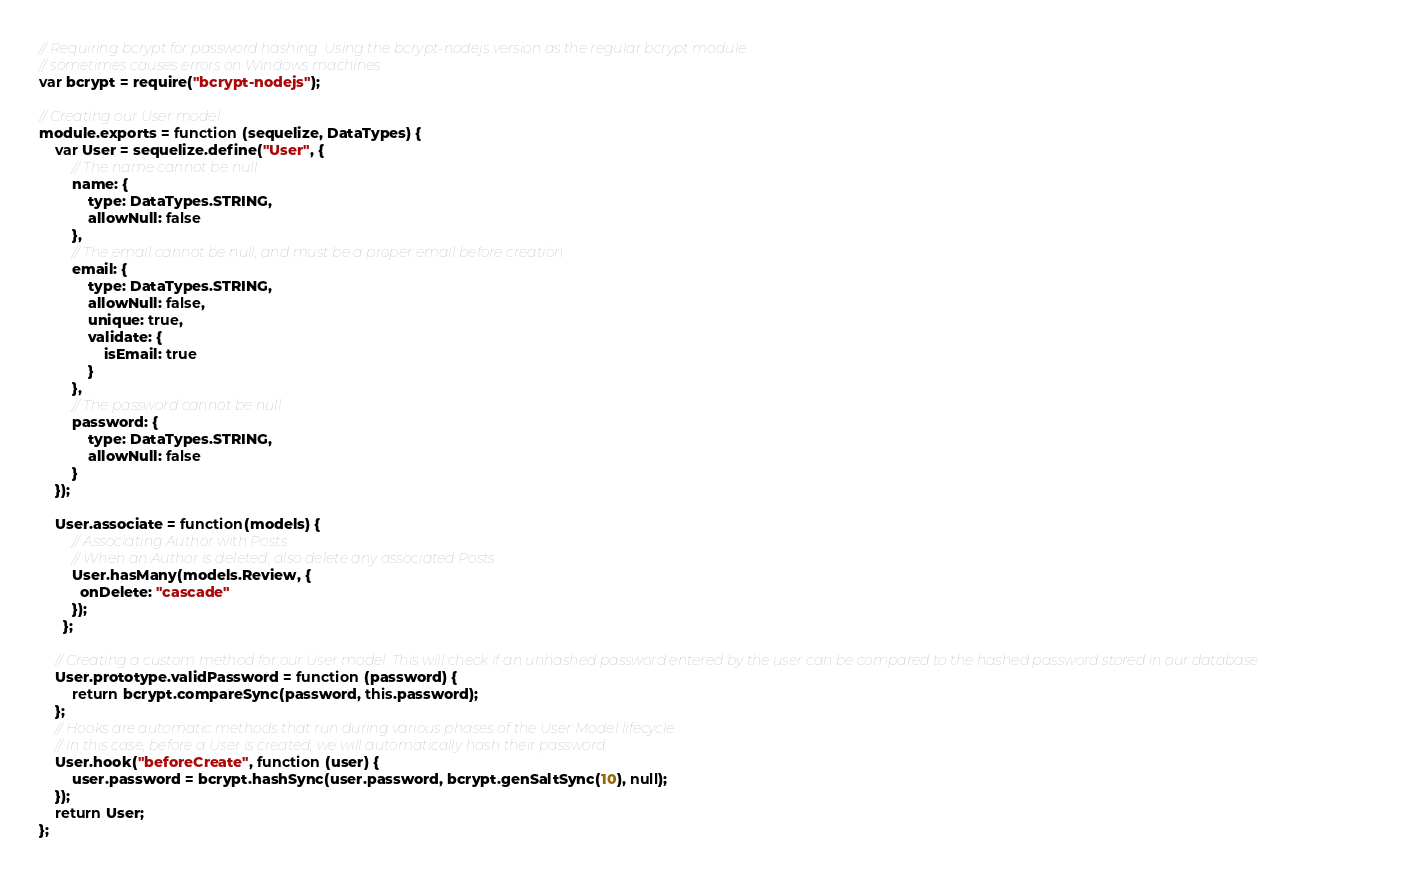Convert code to text. <code><loc_0><loc_0><loc_500><loc_500><_JavaScript_>// Requiring bcrypt for password hashing. Using the bcrypt-nodejs version as the regular bcrypt module
// sometimes causes errors on Windows machines
var bcrypt = require("bcrypt-nodejs");

// Creating our User model
module.exports = function (sequelize, DataTypes) {
    var User = sequelize.define("User", {
        // The name cannot be null
        name: {
            type: DataTypes.STRING,
            allowNull: false
        },
        // The email cannot be null, and must be a proper email before creation
        email: {
            type: DataTypes.STRING,
            allowNull: false,
            unique: true,
            validate: {
                isEmail: true
            }
        },
        // The password cannot be null
        password: {
            type: DataTypes.STRING,
            allowNull: false
        }
    });

    User.associate = function(models) {
        // Associating Author with Posts
        // When an Author is deleted, also delete any associated Posts
        User.hasMany(models.Review, {
          onDelete: "cascade"
        });
      };

    // Creating a custom method for our User model. This will check if an unhashed password entered by the user can be compared to the hashed password stored in our database
    User.prototype.validPassword = function (password) {
        return bcrypt.compareSync(password, this.password);
    };
    // Hooks are automatic methods that run during various phases of the User Model lifecycle
    // In this case, before a User is created, we will automatically hash their password
    User.hook("beforeCreate", function (user) {
        user.password = bcrypt.hashSync(user.password, bcrypt.genSaltSync(10), null);
    });
    return User;
};
</code> 